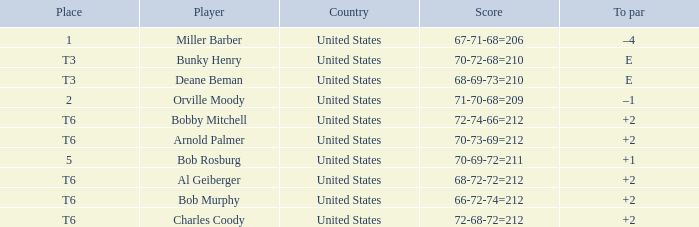What is the to par of player bunky henry? E. 